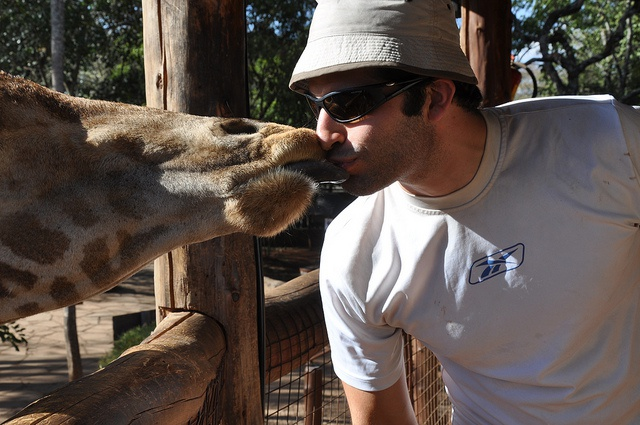Describe the objects in this image and their specific colors. I can see people in black, gray, white, and maroon tones and giraffe in black, maroon, and gray tones in this image. 